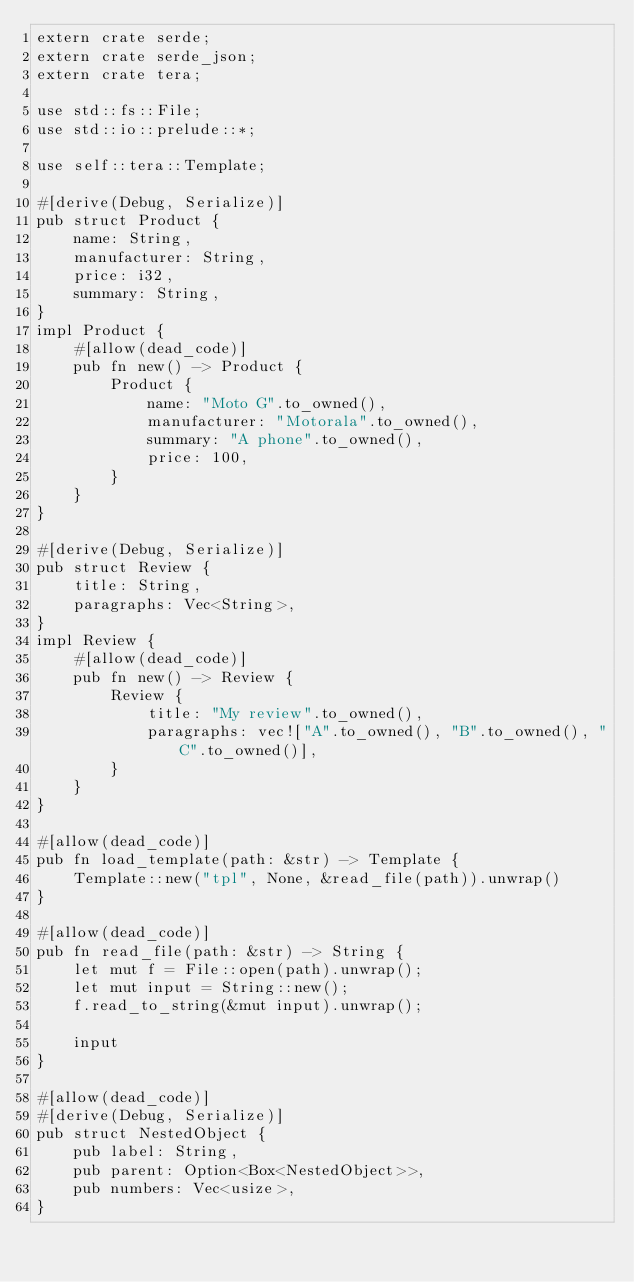<code> <loc_0><loc_0><loc_500><loc_500><_Rust_>extern crate serde;
extern crate serde_json;
extern crate tera;

use std::fs::File;
use std::io::prelude::*;

use self::tera::Template;

#[derive(Debug, Serialize)]
pub struct Product {
    name: String,
    manufacturer: String,
    price: i32,
    summary: String,
}
impl Product {
    #[allow(dead_code)]
    pub fn new() -> Product {
        Product {
            name: "Moto G".to_owned(),
            manufacturer: "Motorala".to_owned(),
            summary: "A phone".to_owned(),
            price: 100,
        }
    }
}

#[derive(Debug, Serialize)]
pub struct Review {
    title: String,
    paragraphs: Vec<String>,
}
impl Review {
    #[allow(dead_code)]
    pub fn new() -> Review {
        Review {
            title: "My review".to_owned(),
            paragraphs: vec!["A".to_owned(), "B".to_owned(), "C".to_owned()],
        }
    }
}

#[allow(dead_code)]
pub fn load_template(path: &str) -> Template {
    Template::new("tpl", None, &read_file(path)).unwrap()
}

#[allow(dead_code)]
pub fn read_file(path: &str) -> String {
    let mut f = File::open(path).unwrap();
    let mut input = String::new();
    f.read_to_string(&mut input).unwrap();

    input
}

#[allow(dead_code)]
#[derive(Debug, Serialize)]
pub struct NestedObject {
    pub label: String,
    pub parent: Option<Box<NestedObject>>,
    pub numbers: Vec<usize>,
}
</code> 